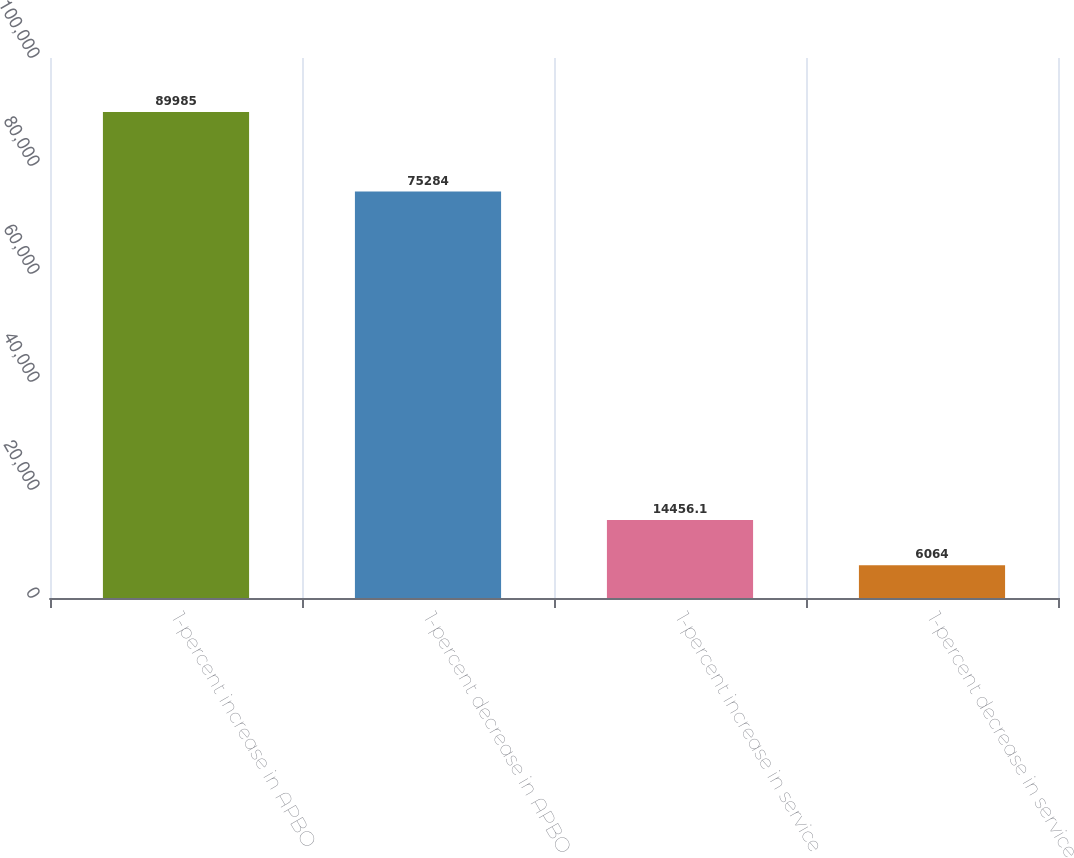<chart> <loc_0><loc_0><loc_500><loc_500><bar_chart><fcel>1-percent increase in APBO<fcel>1-percent decrease in APBO<fcel>1-percent increase in service<fcel>1-percent decrease in service<nl><fcel>89985<fcel>75284<fcel>14456.1<fcel>6064<nl></chart> 